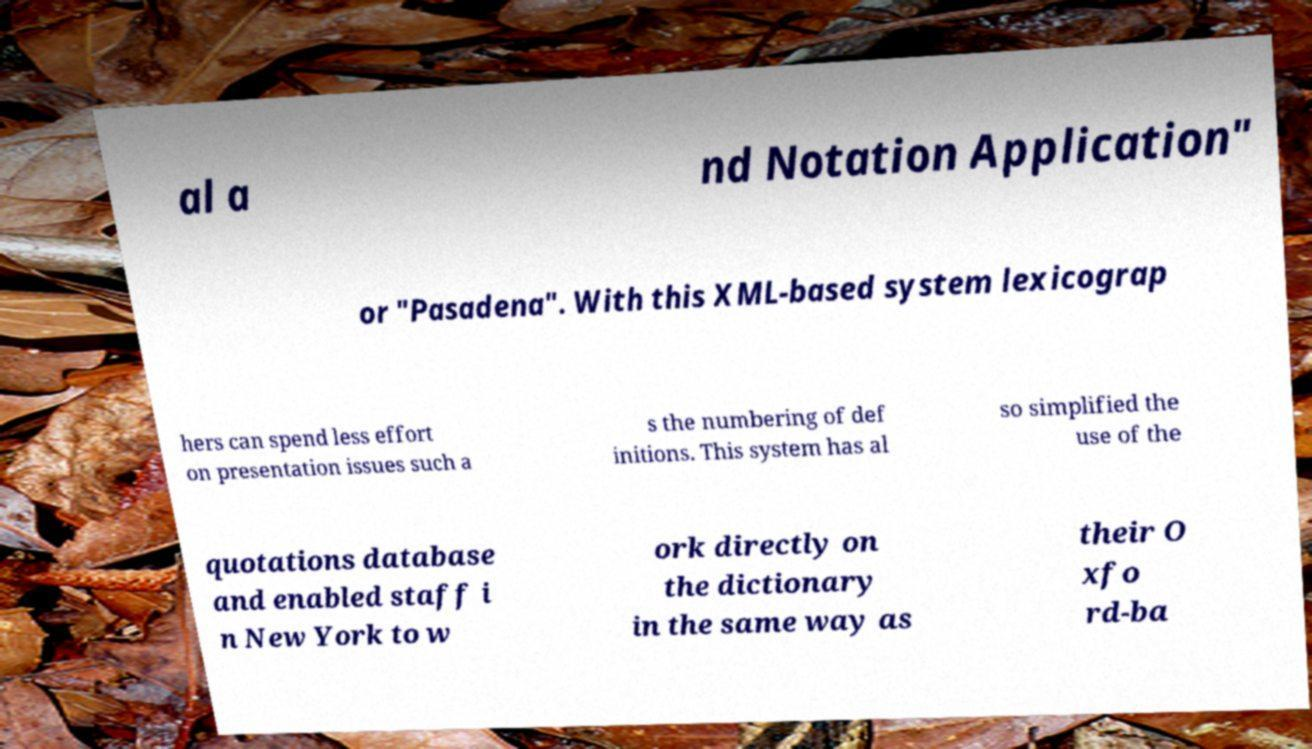Please read and relay the text visible in this image. What does it say? al a nd Notation Application" or "Pasadena". With this XML-based system lexicograp hers can spend less effort on presentation issues such a s the numbering of def initions. This system has al so simplified the use of the quotations database and enabled staff i n New York to w ork directly on the dictionary in the same way as their O xfo rd-ba 